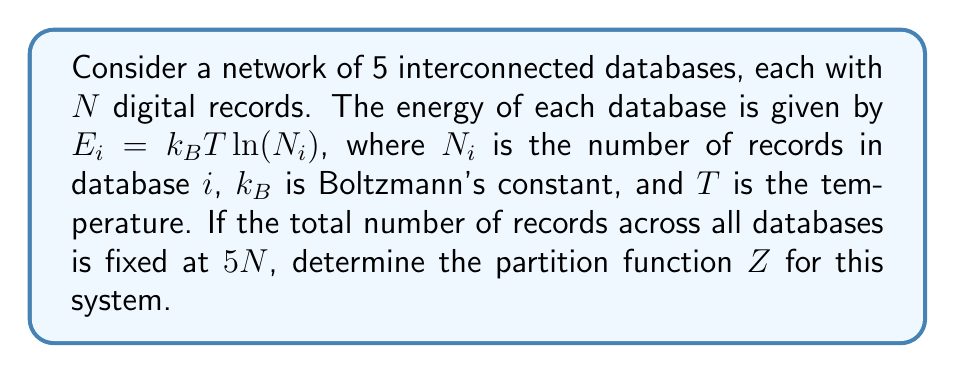Provide a solution to this math problem. To solve this problem, we'll follow these steps:

1) The partition function $Z$ is given by the sum over all possible microstates:

   $$Z = \sum_{\text{all states}} e^{-\beta E}$$

   where $\beta = \frac{1}{k_B T}$

2) In our case, each microstate is a particular distribution of records across the 5 databases. The energy of a microstate is the sum of the energies of each database:

   $$E = \sum_{i=1}^5 E_i = \sum_{i=1}^5 k_B T \ln(N_i)$$

3) Substituting this into the partition function:

   $$Z = \sum_{\text{all states}} \exp\left(-\beta \sum_{i=1}^5 k_B T \ln(N_i)\right)$$

4) Simplify:

   $$Z = \sum_{\text{all states}} \exp\left(-\sum_{i=1}^5 \ln(N_i)\right) = \sum_{\text{all states}} \prod_{i=1}^5 \frac{1}{N_i}$$

5) The sum is over all possible ways to distribute $5N$ records among 5 databases. This is equivalent to the number of ways to place 4 dividers among $5N$ items, which is $\binom{5N+4}{4}$.

6) Therefore, the partition function is:

   $$Z = \binom{5N+4}{4} \cdot \frac{1}{(5N)^5}$$

7) Using the binomial coefficient formula:

   $$Z = \frac{(5N+4)!}{4!(5N)!} \cdot \frac{1}{(5N)^5}$$
Answer: $$Z = \frac{(5N+4)!}{4!(5N)!} \cdot \frac{1}{(5N)^5}$$ 